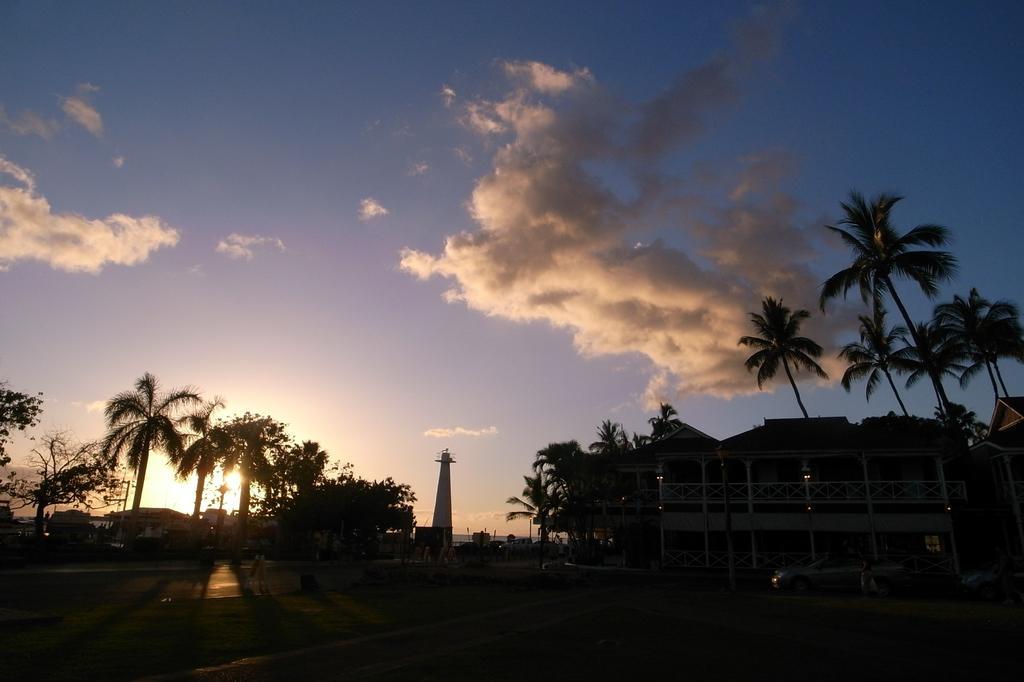How would you summarize this image in a sentence or two? In the picture we can see a path and on the other sides we can see plants, trees and buildings and behind it we can see a sky with clouds. 